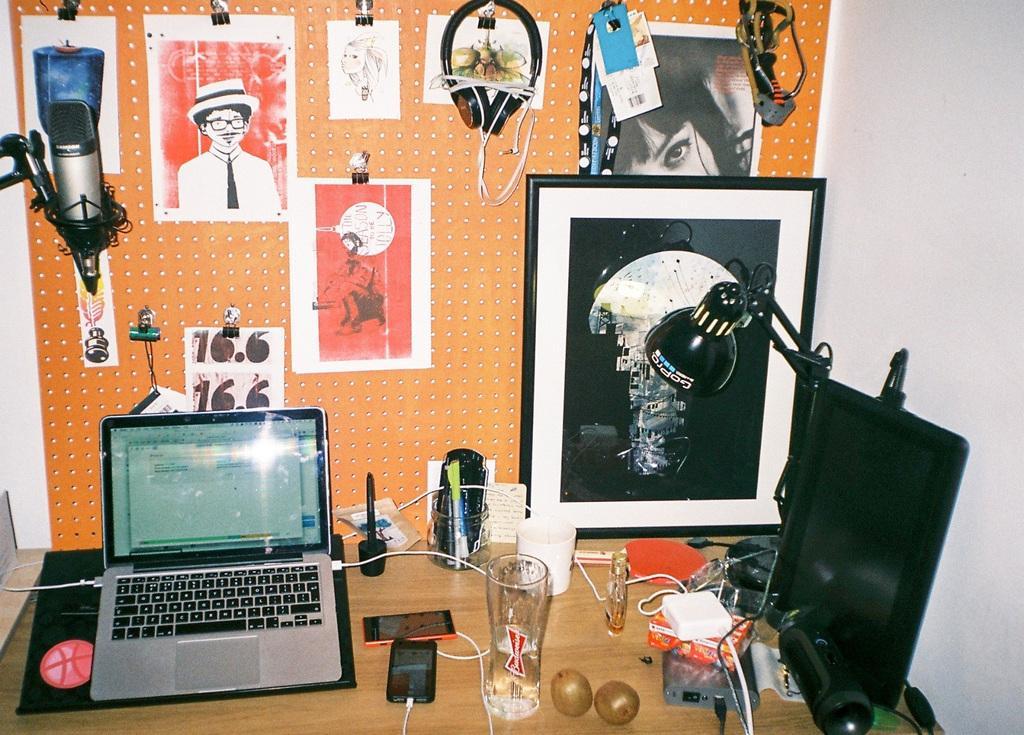Could you give a brief overview of what you see in this image? In this image I can see some objects on the table. In the background, I can see some depictions on the wall. 